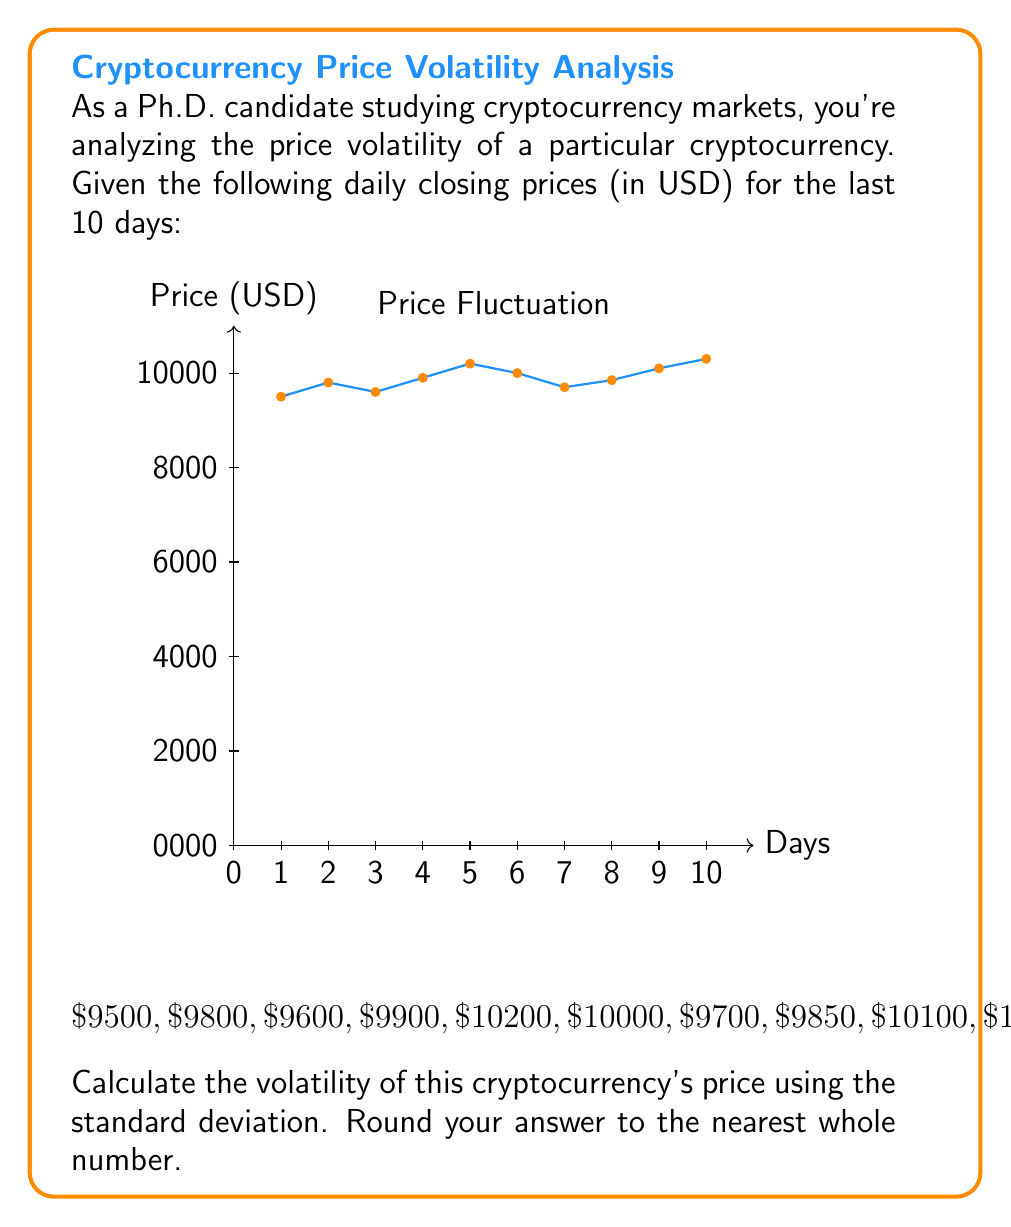Can you answer this question? To calculate the volatility using standard deviation, we'll follow these steps:

1) Calculate the mean (average) price:
   $$\mu = \frac{\sum_{i=1}^{n} x_i}{n}$$
   $$\mu = \frac{9500 + 9800 + 9600 + 9900 + 10200 + 10000 + 9700 + 9850 + 10100 + 10300}{10} = 9895$$

2) Calculate the squared differences from the mean:
   $$(9500 - 9895)^2 = 156025$$
   $$(9800 - 9895)^2 = 9025$$
   $$(9600 - 9895)^2 = 86025$$
   $$(9900 - 9895)^2 = 25$$
   $$(10200 - 9895)^2 = 93025$$
   $$(10000 - 9895)^2 = 11025$$
   $$(9700 - 9895)^2 = 38025$$
   $$(9850 - 9895)^2 = 2025$$
   $$(10100 - 9895)^2 = 42025$$
   $$(10300 - 9895)^2 = 164025$$

3) Sum the squared differences:
   $$\sum_{i=1}^{n} (x_i - \mu)^2 = 601250$$

4) Divide by (n-1) to get the variance:
   $$s^2 = \frac{\sum_{i=1}^{n} (x_i - \mu)^2}{n-1} = \frac{601250}{9} = 66805.56$$

5) Take the square root to get the standard deviation:
   $$s = \sqrt{66805.56} = 258.47$$

6) Round to the nearest whole number:
   $$258.47 \approx 258$$

Therefore, the volatility of the cryptocurrency's price, measured by standard deviation, is approximately 258 USD.
Answer: 258 USD 